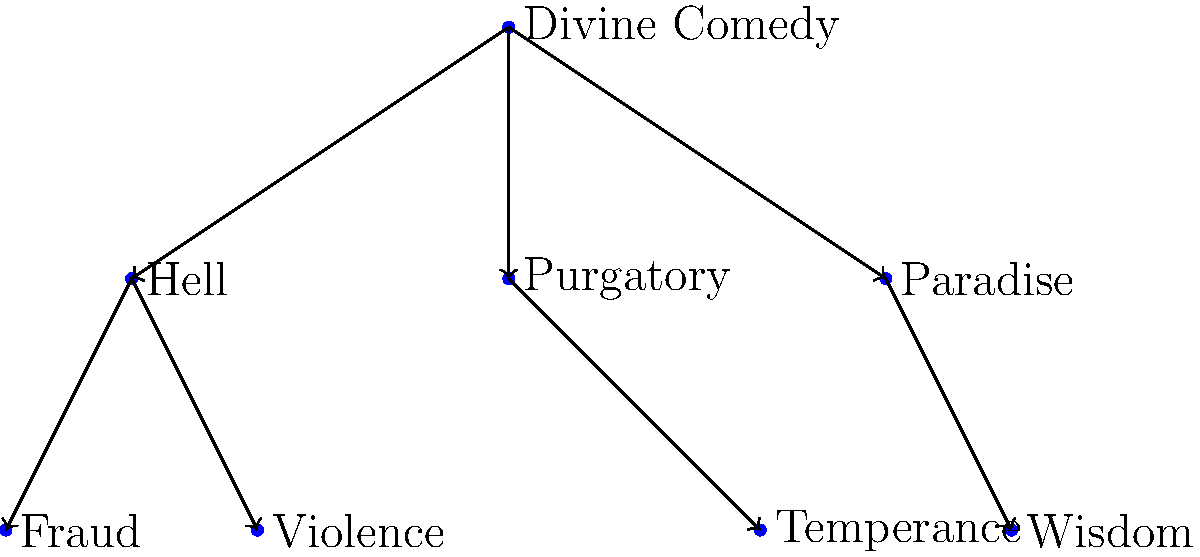In the allegorical structure of Dante's Divine Comedy, which virtue is directly associated with Paradise, and what does this placement suggest about its role in the spiritual journey? To answer this question, let's analyze the structure of the Divine Comedy as represented in the tree diagram:

1. The root node represents the entire Divine Comedy.
2. The three main branches correspond to the three major sections of the work: Hell, Purgatory, and Paradise.
3. Each of these sections is associated with specific virtues or vices.
4. Looking at the Paradise branch, we see that it's directly connected to Wisdom.

This structure suggests several important points:

1. Wisdom is positioned as the primary virtue associated with Paradise.
2. Its placement at the highest level of the diagram (along with Paradise) implies that Wisdom is seen as a culmination of the spiritual journey.
3. The direct connection between Paradise and Wisdom suggests that this virtue is essential for reaching the ultimate spiritual goal in Dante's cosmology.
4. Compared to the lower virtues (like Temperance in Purgatory) or the vices in Hell, Wisdom occupies a privileged position, indicating its supreme importance in Dante's moral and spiritual hierarchy.
5. This placement aligns with the medieval Christian concept of the Seven Heavenly Virtues, where Wisdom (or Prudence) is often considered one of the highest virtues.

In Dante's allegory, this structure implies that the attainment of true Wisdom is synonymous with reaching Paradise, representing the highest level of spiritual enlightenment and closeness to the divine.
Answer: Wisdom 